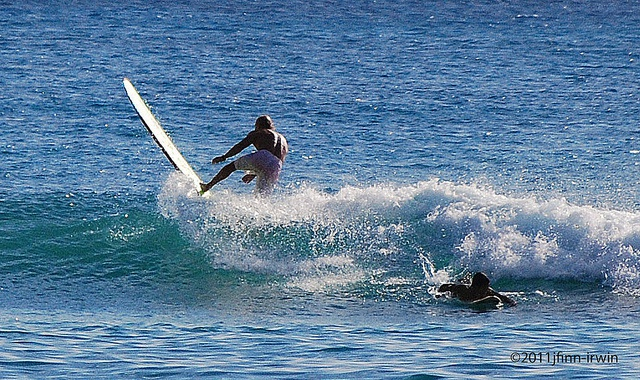Describe the objects in this image and their specific colors. I can see people in blue, black, gray, darkgray, and navy tones, surfboard in blue, white, darkgray, black, and beige tones, people in blue, black, gray, darkgray, and lightgray tones, and surfboard in blue, black, gray, white, and darkgray tones in this image. 